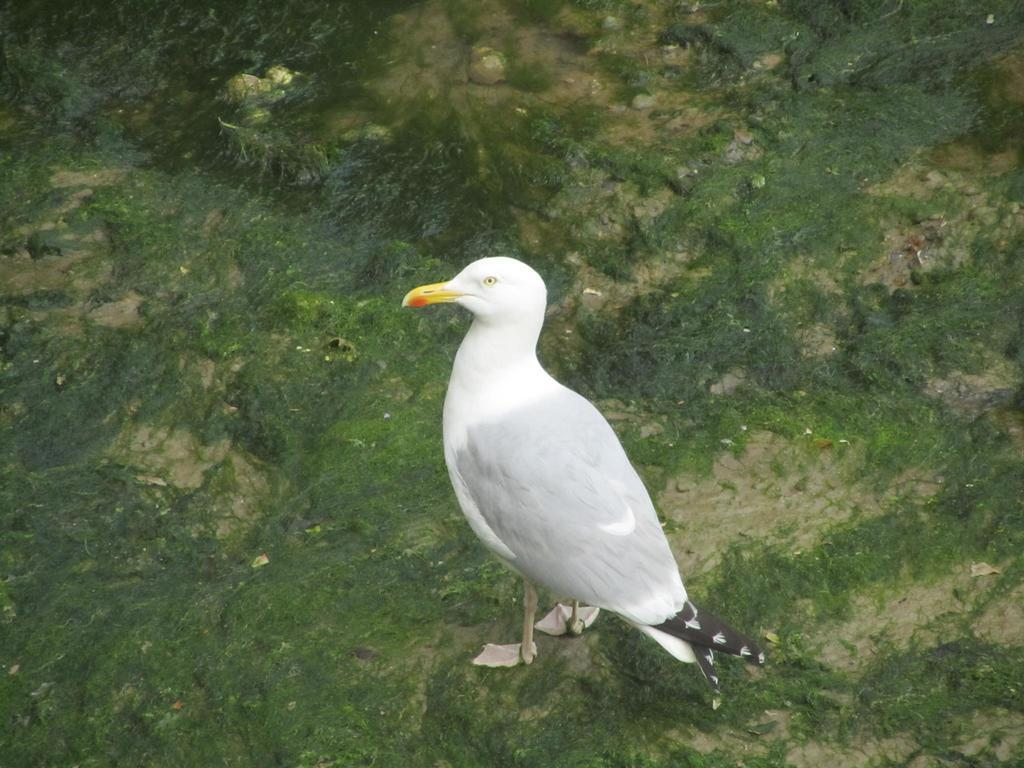What type of animal is in the image? There is a bird in the image. What color is the bird? The bird is white in color. What type of surface is visible in the image? There is ground visible in the image. What is the color and texture of the vegetation on the ground? Green grass is present on the ground. What finger is the bird using to read a book in the image? There is no book or finger present in the image; it features a white bird on the ground. 